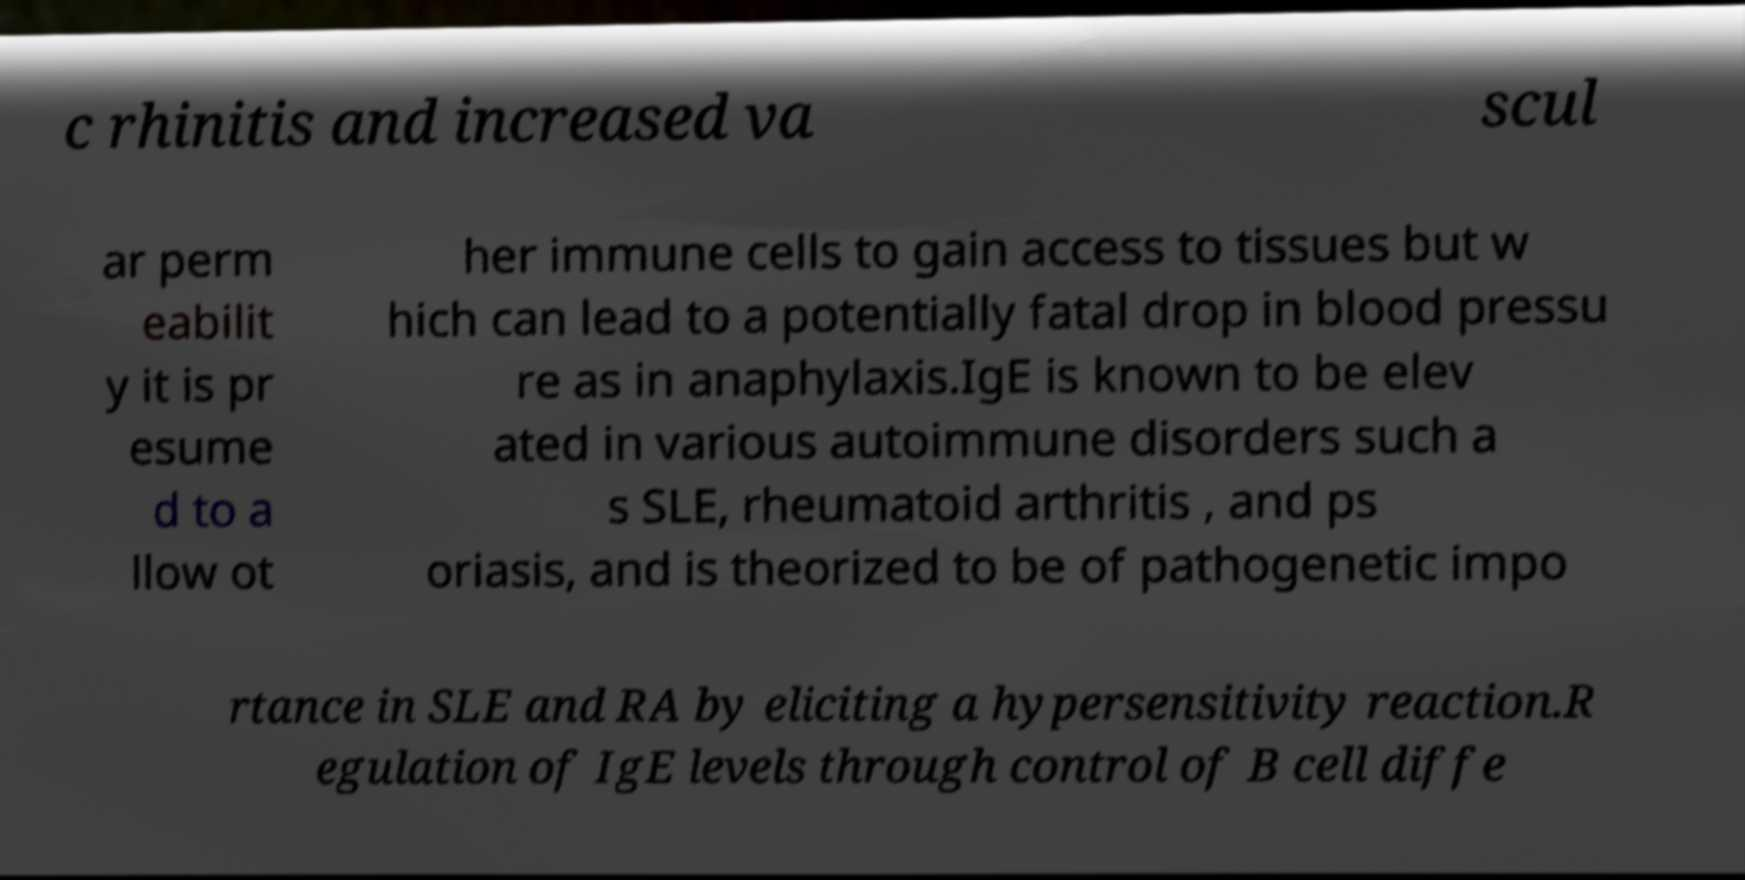There's text embedded in this image that I need extracted. Can you transcribe it verbatim? c rhinitis and increased va scul ar perm eabilit y it is pr esume d to a llow ot her immune cells to gain access to tissues but w hich can lead to a potentially fatal drop in blood pressu re as in anaphylaxis.IgE is known to be elev ated in various autoimmune disorders such a s SLE, rheumatoid arthritis , and ps oriasis, and is theorized to be of pathogenetic impo rtance in SLE and RA by eliciting a hypersensitivity reaction.R egulation of IgE levels through control of B cell diffe 